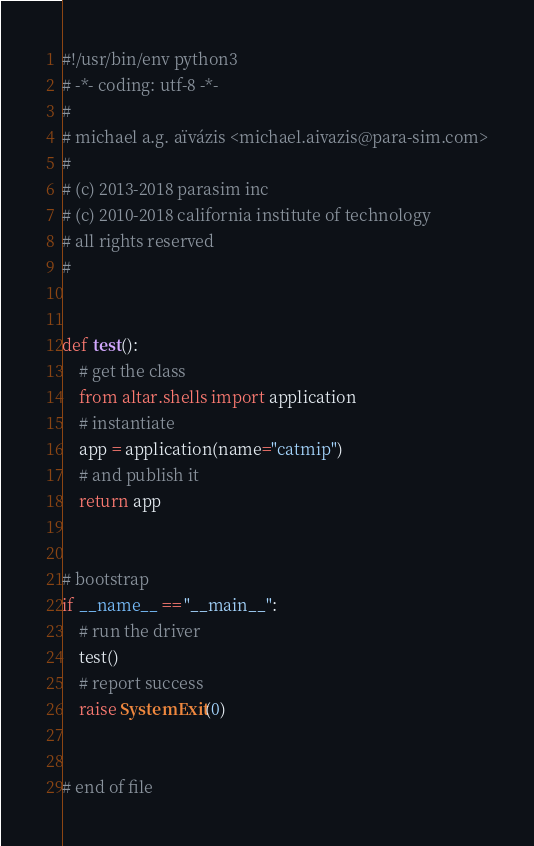<code> <loc_0><loc_0><loc_500><loc_500><_Python_>#!/usr/bin/env python3
# -*- coding: utf-8 -*-
#
# michael a.g. aïvázis <michael.aivazis@para-sim.com>
#
# (c) 2013-2018 parasim inc
# (c) 2010-2018 california institute of technology
# all rights reserved
#


def test():
    # get the class
    from altar.shells import application
    # instantiate
    app = application(name="catmip")
    # and publish it
    return app


# bootstrap
if __name__ == "__main__":
    # run the driver
    test()
    # report success
    raise SystemExit(0)


# end of file
</code> 